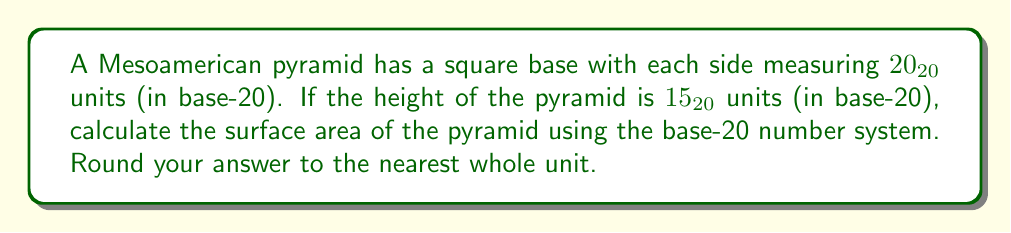Could you help me with this problem? To solve this problem, we need to follow these steps:

1) First, let's convert the given measurements from base-20 to base-10:

   Side length: $20_{20} = 20 * 20 = 400_{10}$
   Height: $15_{20} = 1 * 20 + 5 = 25_{10}$

2) The surface area of a square pyramid is given by the formula:
   $$ A = s^2 + 2s\sqrt{\frac{s^2}{4} + h^2} $$
   where $s$ is the side length of the base and $h$ is the height.

3) Let's substitute our values:
   $$ A = 400^2 + 2(400)\sqrt{\frac{400^2}{4} + 25^2} $$

4) Simplify:
   $$ A = 160,000 + 800\sqrt{40,000 + 625} $$
   $$ A = 160,000 + 800\sqrt{40,625} $$
   $$ A = 160,000 + 800(201.5574) $$
   $$ A = 160,000 + 161,245.92 $$
   $$ A = 321,245.92 $$

5) Rounding to the nearest whole number:
   $$ A \approx 321,246_{10} $$

6) Now, we need to convert this back to base-20. We can do this by repeatedly dividing by 20 and taking the remainders:

   321,246 ÷ 20 = 16,062 remainder 6
   16,062 ÷ 20 = 803 remainder 2
   803 ÷ 20 = 40 remainder 3
   40 ÷ 20 = 2 remainder 0
   2 ÷ 20 = 0 remainder 2

   Reading the remainders from bottom to top, we get:

   $$ A \approx 20,306_{20} $$

Thus, the surface area of the pyramid in base-20 is approximately $20,306_{20}$ square units.
Answer: $20,306_{20}$ square units 